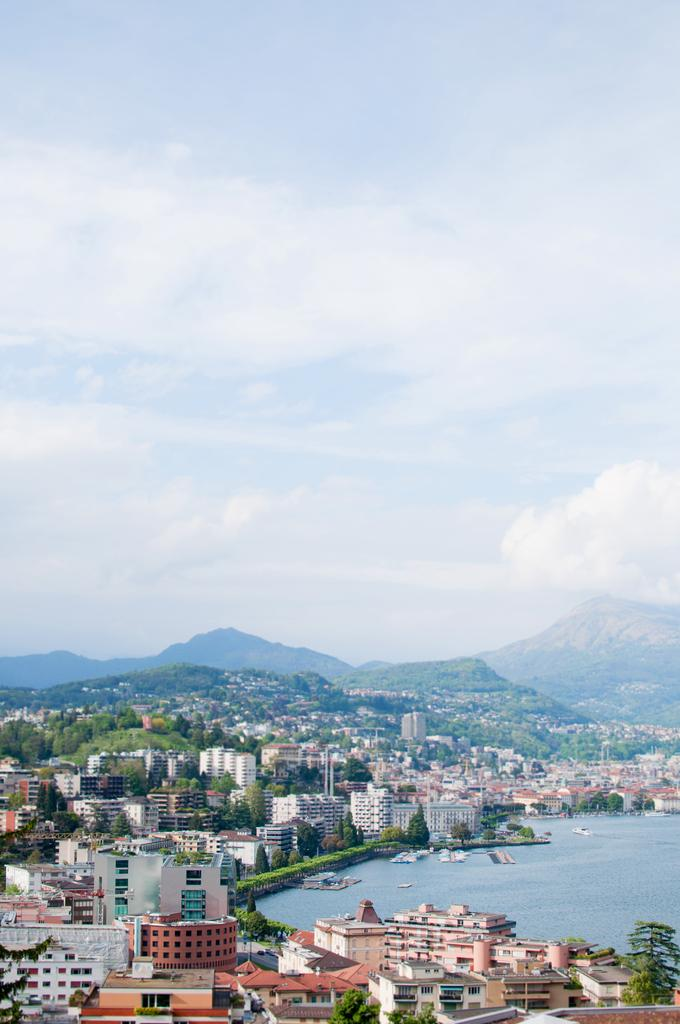What type of structures are present in the image? There are houses and buildings in the image. What natural feature can be seen on the right side of the image? There is a pond on the right side of the image. What is visible at the top of the image? The sky is visible at the top of the image. How would you describe the weather based on the appearance of the sky? The sky appears to be cloudy in the image. Can you see any twigs floating in the pond in the image? There is no mention of twigs in the image, so it cannot be determined if any are present. 